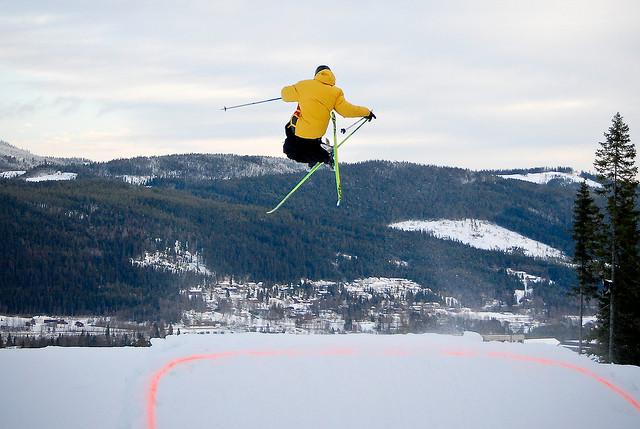What is the skier wearing to protect his head?
Short answer required. Helmet. What sport is this person participating in?
Write a very short answer. Skiing. What color is the coat?
Write a very short answer. Yellow. Are the feet of the man in the yellow shirt touching the skateboard?
Answer briefly. No. What color other than white is seen on the ground?
Answer briefly. Orange. What color is the snowsuit?
Write a very short answer. Yellow. Is this man flying?
Answer briefly. No. 